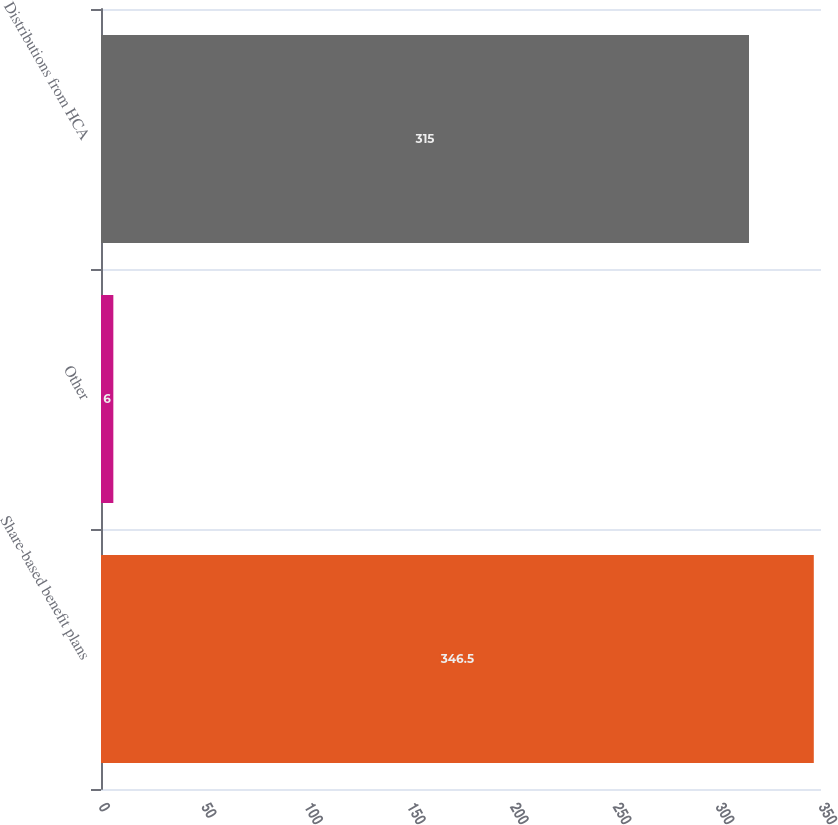<chart> <loc_0><loc_0><loc_500><loc_500><bar_chart><fcel>Share-based benefit plans<fcel>Other<fcel>Distributions from HCA<nl><fcel>346.5<fcel>6<fcel>315<nl></chart> 